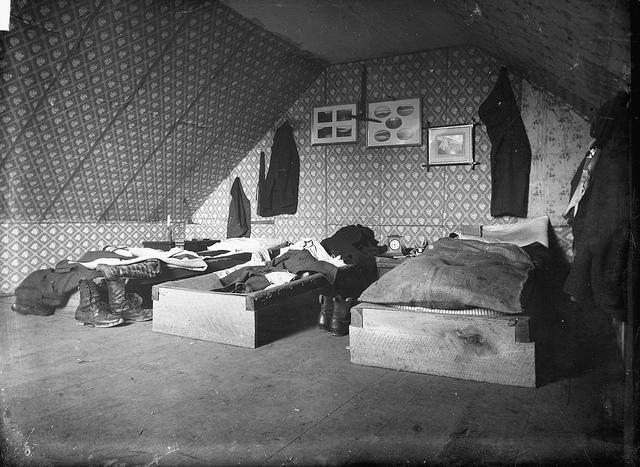How many pairs of boots are visible?
Short answer required. 2. Are there pictures on the wall?
Answer briefly. Yes. Are the bed frames wooden?
Answer briefly. Yes. 